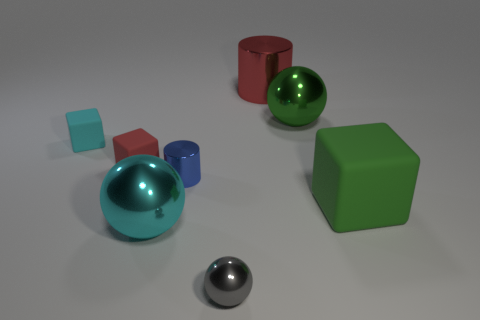The matte cube that is the same color as the big metallic cylinder is what size?
Provide a succinct answer. Small. There is a red thing behind the tiny cyan thing; does it have the same size as the shiny object that is in front of the big cyan ball?
Your answer should be compact. No. There is a cyan thing that is on the right side of the cyan rubber thing; what is its size?
Offer a terse response. Large. Are there any things of the same color as the tiny cylinder?
Your answer should be compact. No. There is a shiny cylinder to the left of the big red cylinder; is there a small red thing right of it?
Your response must be concise. No. There is a red matte block; does it have the same size as the metal cylinder that is in front of the small cyan thing?
Offer a very short reply. Yes. Are there any metal cylinders to the right of the big green object to the right of the green object left of the big green rubber thing?
Make the answer very short. No. What is the large sphere in front of the green sphere made of?
Keep it short and to the point. Metal. Does the red matte block have the same size as the cyan rubber block?
Offer a terse response. Yes. What color is the shiny ball that is in front of the tiny red cube and behind the tiny gray thing?
Provide a short and direct response. Cyan. 